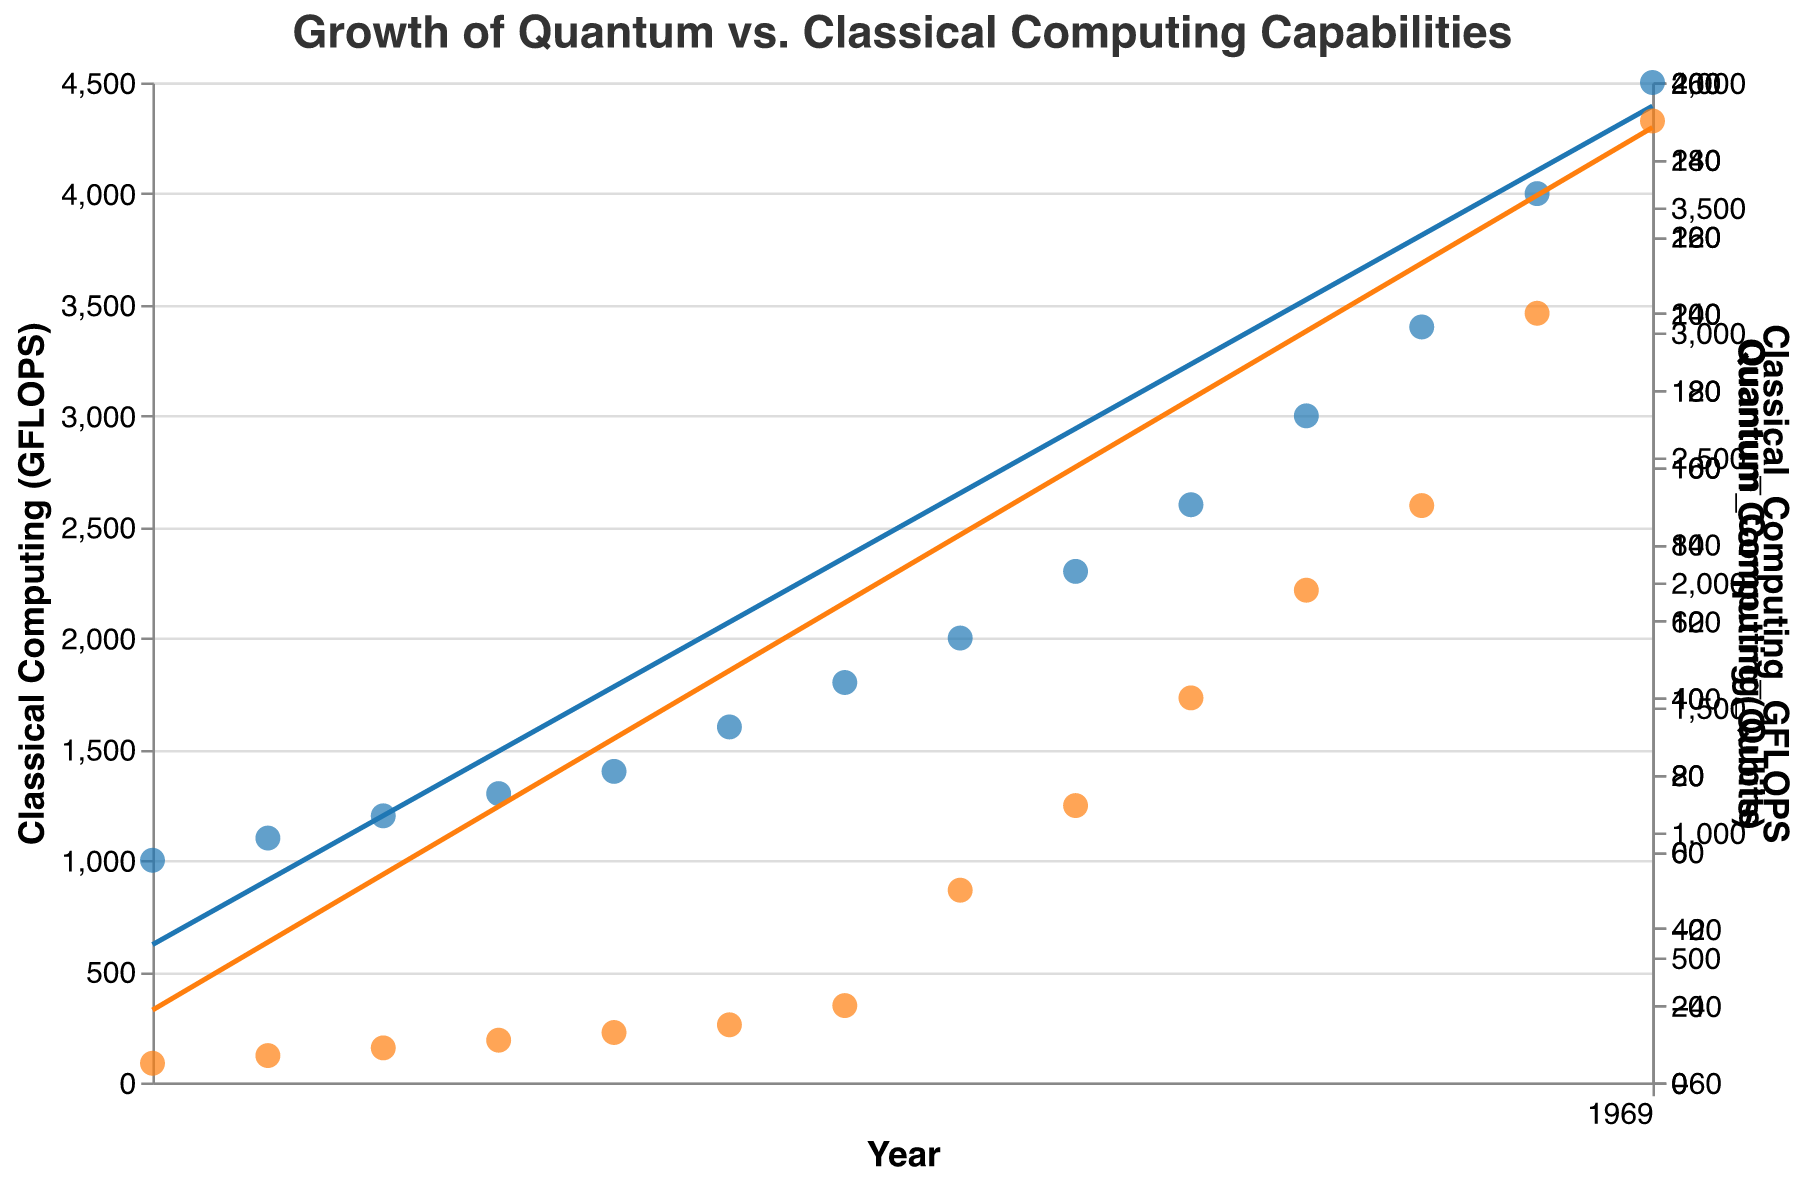How does the title of the plot read? The title is located at the top of the plot. By reading the text there, we can determine the exact phrasing used.
Answer: Growth of Quantum vs. Classical Computing Capabilities What are the colors representing Classical and Quantum computing data points? The colors of the data points are visually different. The legend or the points themselves indicate Classical Computing is blue and Quantum Computing is orange.
Answer: Classical Computing: Blue, Quantum Computing: Orange How many qubits were used in quantum computing in 2021? Locate the year 2021 on the x-axis and observe the corresponding orange data point on the y-axis, which reads the number of qubits for that year.
Answer: 150 What is the general trend in Classical Computing GFLOPS over the years? The blue trend line represents the general trend of Classical Computing GFLOPS over time. By observing the direction and slope of the line, we can describe the trend.
Answer: Increasing What is the difference in performance between Quantum and Classical computing in 2018? Locate the year 2018 on the x-axis. Observe the GFLOPS for Classical Computing and the number of qubits for Quantum Computing, then subtract the two values.
Answer: 2228 GFLOPS (2300 GFLOPS - 72 Qubits) How do the scales of the y-axes differ for Classical and Quantum computing? Observe the y-axis on both sides of the plot noting the range of values and the title descriptions on each axis to understand if they are independent and different.
Answer: Independent and different scales Which year shows the largest increase in qubits for Quantum computing? By looking at the plot, find the year-to-year qubit increases by examining the orange data points. Calculate the differences year over year, and identify the largest increase.
Answer: 2017 (increase from 20 to 50) Compare the slopes of the trend lines for Classical and Quantum computing. Which grows faster? By examining the angles of the trend lines, we can compare their slopes. The steeper line indicates faster growth.
Answer: Quantum computing grows faster What is the GFLOPS for Classical Computing in the year 2020? Locate the year 2020 on the x-axis and observe the corresponding blue data point on the y-axis, which indicates the number of GFLOPS for that year.
Answer: 3000 GFLOPS When did Quantum Computing reach 200 qubits? Locate the y-axis point for 200 qubits, then trace it horizontally to intersect with the orange data points. Identify the corresponding year on the x-axis.
Answer: 2022 